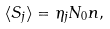Convert formula to latex. <formula><loc_0><loc_0><loc_500><loc_500>\langle { S } _ { j } \rangle = \eta _ { j } N _ { 0 } { n } ,</formula> 